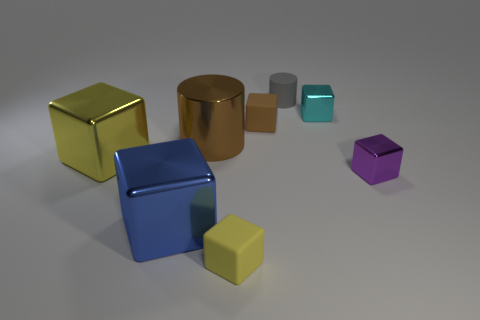Subtract all small shiny blocks. How many blocks are left? 4 Subtract all cubes. How many objects are left? 2 Subtract 4 cubes. How many cubes are left? 2 Subtract all gray cylinders. How many cylinders are left? 1 Subtract 0 green cylinders. How many objects are left? 8 Subtract all red cylinders. Subtract all yellow balls. How many cylinders are left? 2 Subtract all green cylinders. How many gray cubes are left? 0 Subtract all tiny yellow rubber blocks. Subtract all cubes. How many objects are left? 1 Add 4 yellow objects. How many yellow objects are left? 6 Add 6 big blue shiny things. How many big blue shiny things exist? 7 